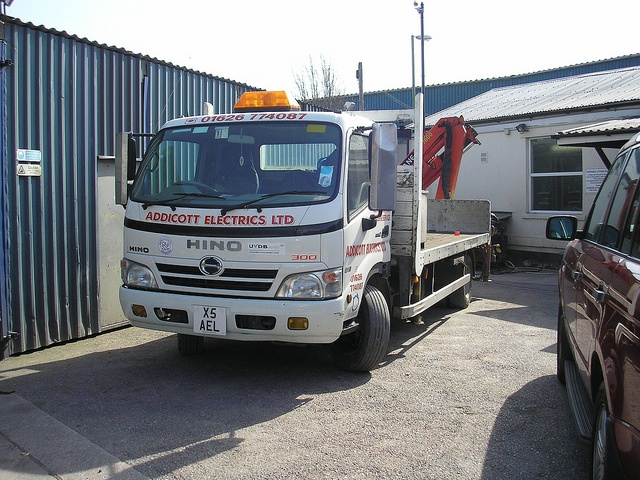Describe the objects in this image and their specific colors. I can see truck in darkblue, darkgray, black, gray, and blue tones and car in darkblue, black, gray, and darkgray tones in this image. 